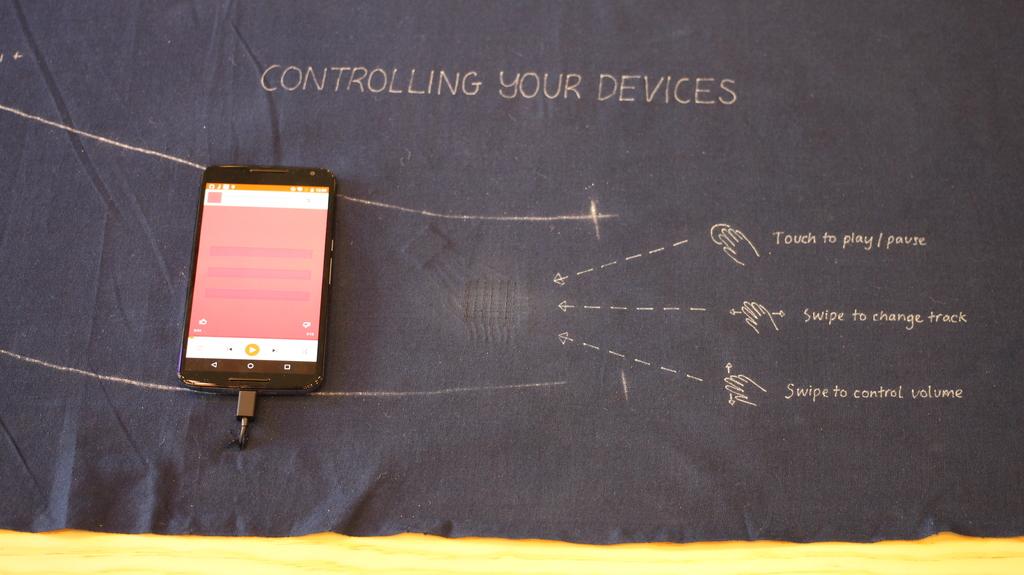Do you touch or swipe to control volume?
Your answer should be very brief. Swipe. Controlling your what?
Offer a terse response. Devices. 